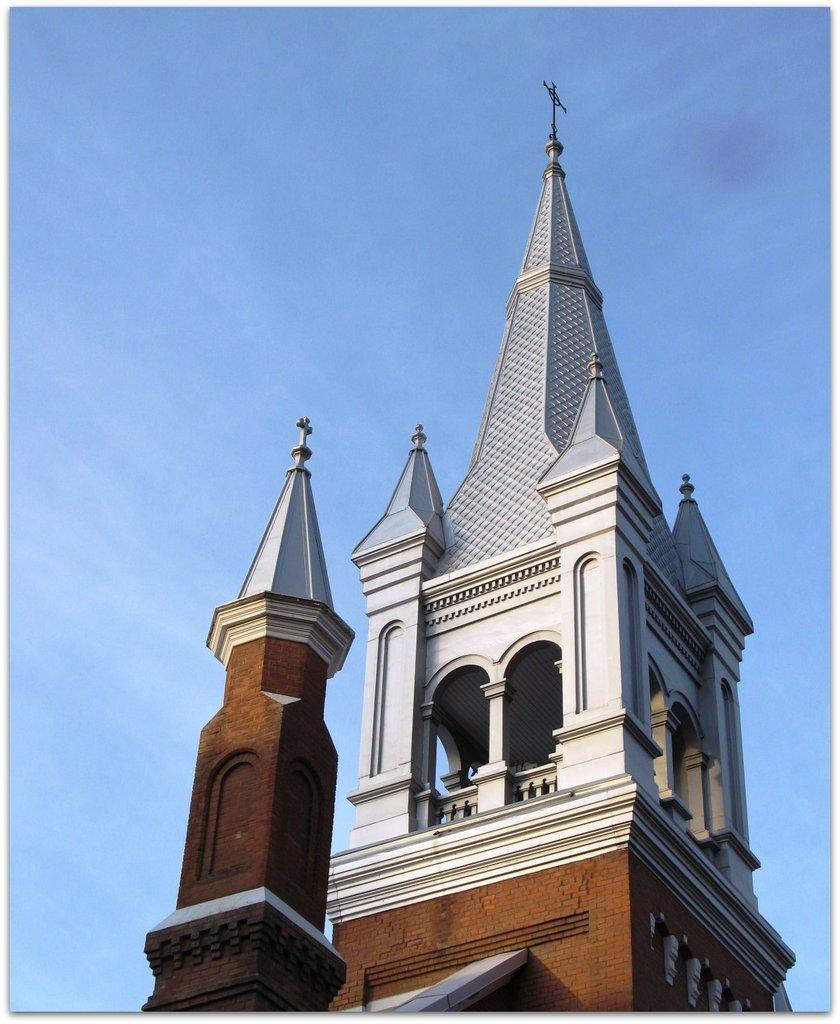What type of building is in the image? There is a church in the image. What is visible at the top of the image? The sky is visible at the top of the image. What type of thread is being used to drive the gold in the image? There is no thread or gold present in the image; it only features a church and the sky. 